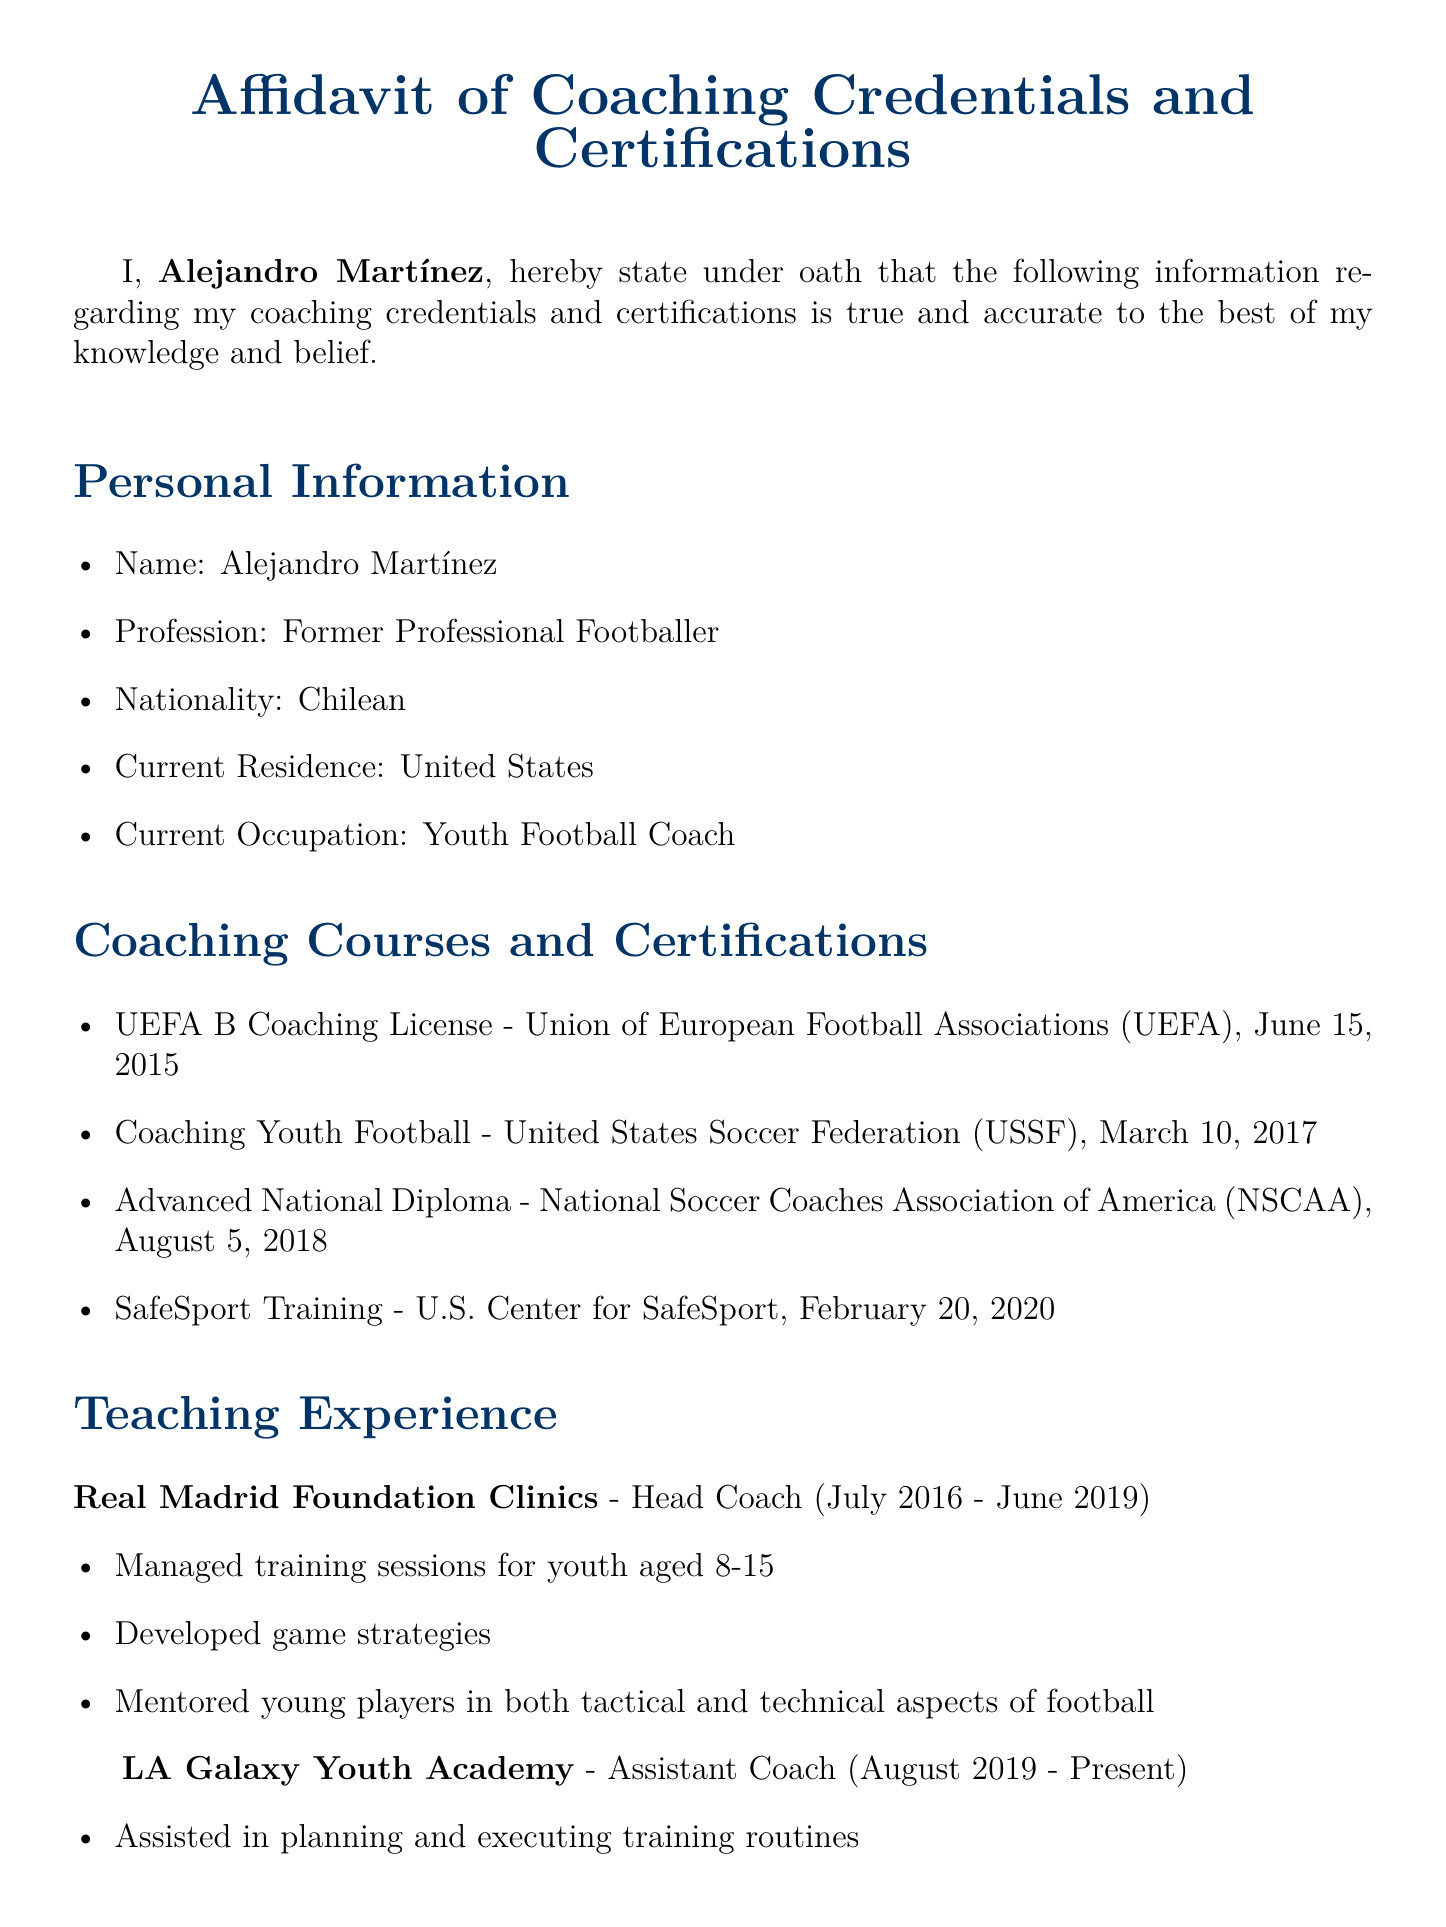What is the name of the affiant? The affiant is the person making the affidavit, which in this case is Alejandro Martínez.
Answer: Alejandro Martínez When did Alejandro Martínez obtain his UEFA B Coaching License? The date of the coaching license is specified in the document under coaching courses, which is June 15, 2015.
Answer: June 15, 2015 What position did Alejandro Martínez hold at Real Madrid Foundation Clinics? The document specifies that he was the Head Coach at that institution.
Answer: Head Coach Which academy does Alejandro Martínez currently work for? The document indicates that he is currently working for the LA Galaxy Youth Academy.
Answer: LA Galaxy Youth Academy What training did Alejandro Martínez complete on February 20, 2020? This question refers to the specific certification completed on that date, which is SafeSport Training.
Answer: SafeSport Training How long did Alejandro Martínez coach at Real Madrid Foundation Clinics? The period he worked there is mentioned in the document as July 2016 - June 2019, which denotes a span of three years.
Answer: Three years What is Alejandro Martínez's nationality? The document states his nationality directly as Chilean.
Answer: Chilean What role does Alejandro Martínez fulfill at the LA Galaxy Youth Academy? The document mentions that he serves as an Assistant Coach at this academy.
Answer: Assistant Coach What is the purpose of signing the affidavit according to the declaration section? The declaration section emphasizes that the affiant affirms the truthfulness and accuracy of the information provided in the affidavit.
Answer: Truthfulness and accuracy 